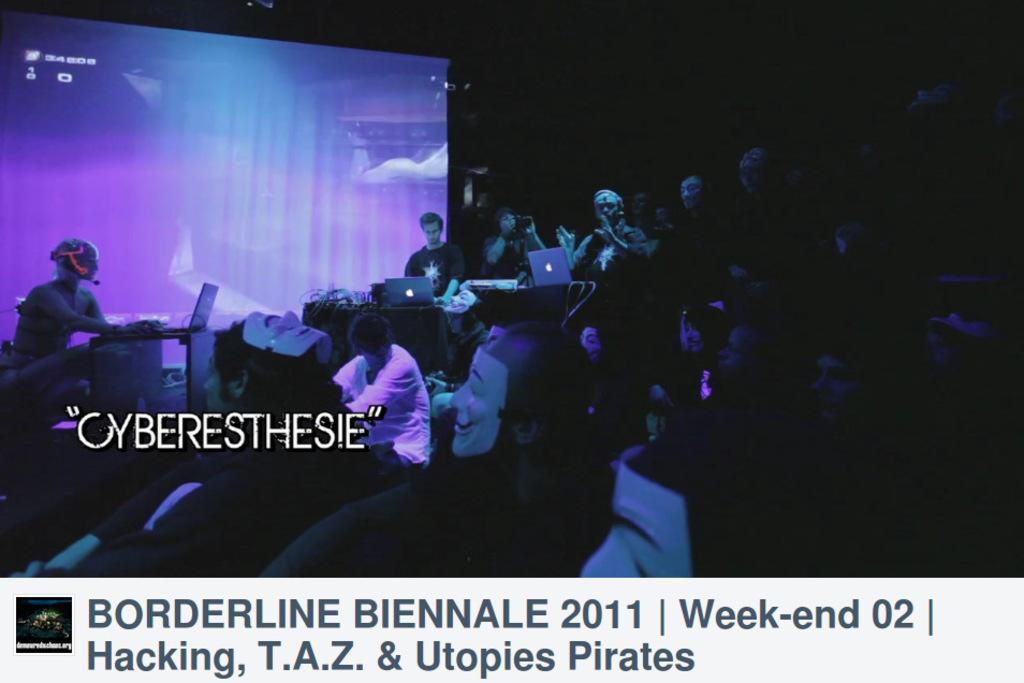Describe this image in one or two sentences. In this picture we can see a group of people, here we can see laptops, projector screen, tables and some objects and in the background we can see it is dark, at the bottom we can see some text on it. 